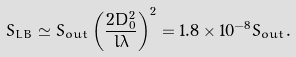<formula> <loc_0><loc_0><loc_500><loc_500>S _ { L B } \simeq S _ { o u t } \left ( \frac { 2 D _ { 0 } ^ { 2 } } { l \lambda } \right ) ^ { 2 } = 1 . 8 \times 1 0 ^ { - 8 } S _ { o u t } .</formula> 